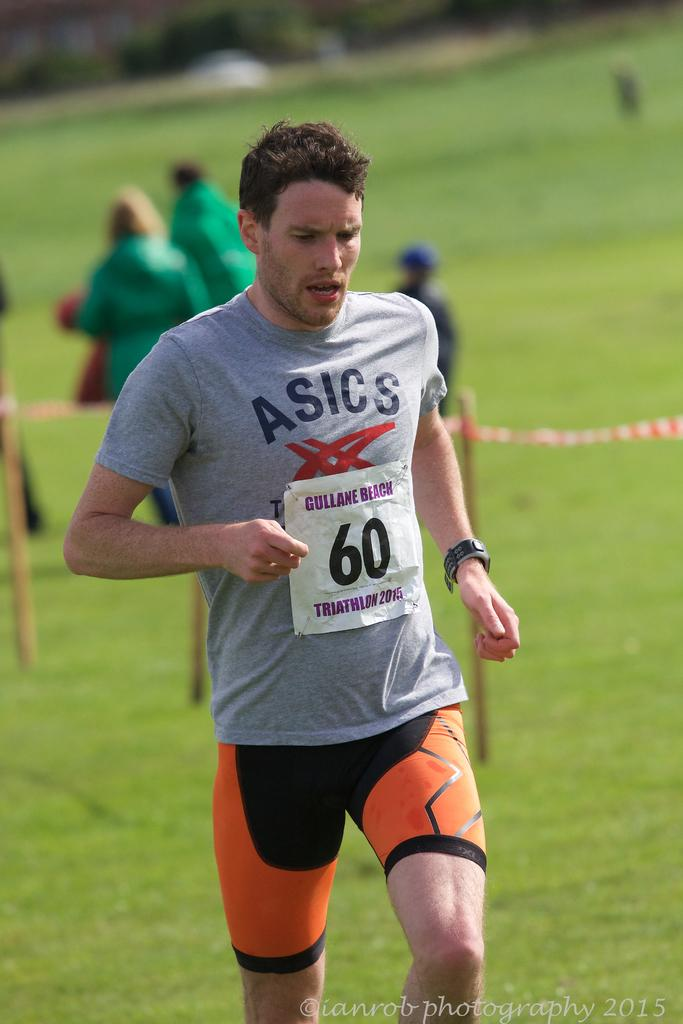How many people are in the image? There are people in the image, but the exact number is not specified. What is one person doing in the image? One person is running in the image. What can be seen connecting the poles in the image? There is a thread tied to poles in the image. What is the condition of the background in the image? The background of the image is blurred. What type of hose is being used by the children in the image? There are no children or hoses present in the image. What color is the cloth draped over the poles in the image? There is no cloth draped over the poles in the image; it is a thread connecting the poles. 